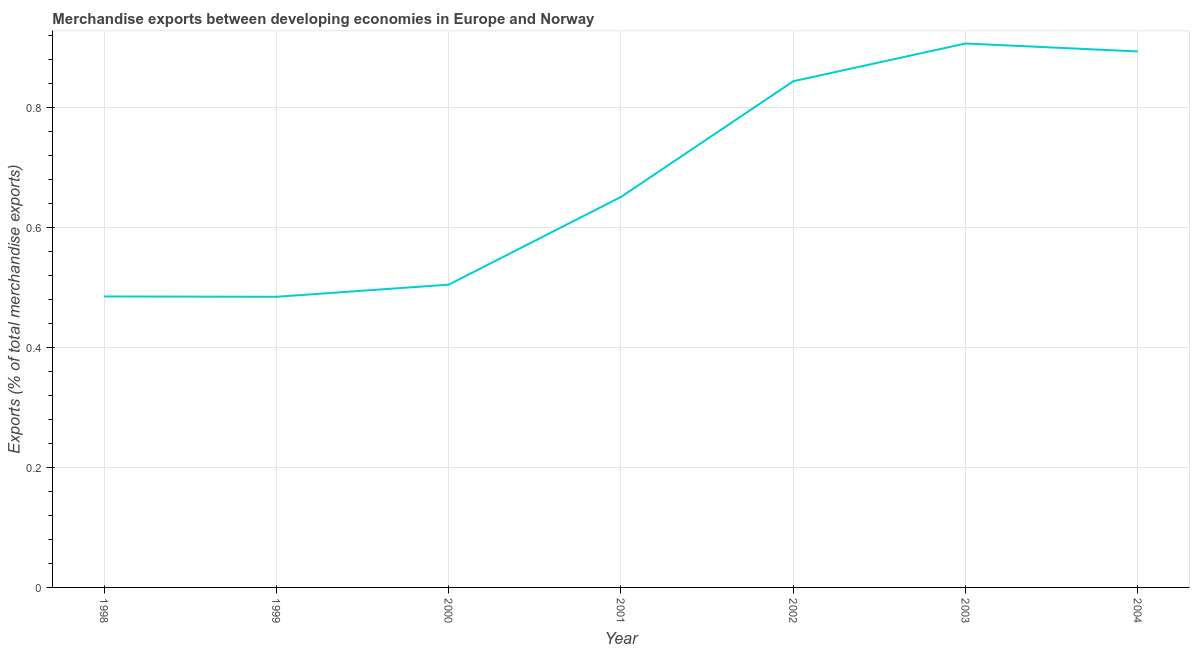What is the merchandise exports in 1998?
Your response must be concise. 0.49. Across all years, what is the maximum merchandise exports?
Provide a short and direct response. 0.91. Across all years, what is the minimum merchandise exports?
Ensure brevity in your answer.  0.48. In which year was the merchandise exports maximum?
Make the answer very short. 2003. In which year was the merchandise exports minimum?
Your response must be concise. 1999. What is the sum of the merchandise exports?
Your response must be concise. 4.77. What is the difference between the merchandise exports in 2003 and 2004?
Offer a very short reply. 0.01. What is the average merchandise exports per year?
Give a very brief answer. 0.68. What is the median merchandise exports?
Ensure brevity in your answer.  0.65. What is the ratio of the merchandise exports in 1998 to that in 2000?
Provide a short and direct response. 0.96. Is the difference between the merchandise exports in 2002 and 2004 greater than the difference between any two years?
Keep it short and to the point. No. What is the difference between the highest and the second highest merchandise exports?
Make the answer very short. 0.01. Is the sum of the merchandise exports in 1998 and 1999 greater than the maximum merchandise exports across all years?
Your answer should be compact. Yes. What is the difference between the highest and the lowest merchandise exports?
Give a very brief answer. 0.42. Does the merchandise exports monotonically increase over the years?
Offer a very short reply. No. Are the values on the major ticks of Y-axis written in scientific E-notation?
Offer a terse response. No. Does the graph contain any zero values?
Your answer should be very brief. No. What is the title of the graph?
Offer a very short reply. Merchandise exports between developing economies in Europe and Norway. What is the label or title of the X-axis?
Offer a very short reply. Year. What is the label or title of the Y-axis?
Make the answer very short. Exports (% of total merchandise exports). What is the Exports (% of total merchandise exports) in 1998?
Offer a very short reply. 0.49. What is the Exports (% of total merchandise exports) of 1999?
Give a very brief answer. 0.48. What is the Exports (% of total merchandise exports) of 2000?
Offer a very short reply. 0.51. What is the Exports (% of total merchandise exports) of 2001?
Your answer should be compact. 0.65. What is the Exports (% of total merchandise exports) in 2002?
Make the answer very short. 0.84. What is the Exports (% of total merchandise exports) in 2003?
Ensure brevity in your answer.  0.91. What is the Exports (% of total merchandise exports) of 2004?
Offer a terse response. 0.89. What is the difference between the Exports (% of total merchandise exports) in 1998 and 1999?
Ensure brevity in your answer.  0. What is the difference between the Exports (% of total merchandise exports) in 1998 and 2000?
Make the answer very short. -0.02. What is the difference between the Exports (% of total merchandise exports) in 1998 and 2001?
Make the answer very short. -0.17. What is the difference between the Exports (% of total merchandise exports) in 1998 and 2002?
Your answer should be compact. -0.36. What is the difference between the Exports (% of total merchandise exports) in 1998 and 2003?
Your response must be concise. -0.42. What is the difference between the Exports (% of total merchandise exports) in 1998 and 2004?
Offer a very short reply. -0.41. What is the difference between the Exports (% of total merchandise exports) in 1999 and 2000?
Make the answer very short. -0.02. What is the difference between the Exports (% of total merchandise exports) in 1999 and 2001?
Provide a short and direct response. -0.17. What is the difference between the Exports (% of total merchandise exports) in 1999 and 2002?
Offer a very short reply. -0.36. What is the difference between the Exports (% of total merchandise exports) in 1999 and 2003?
Your answer should be compact. -0.42. What is the difference between the Exports (% of total merchandise exports) in 1999 and 2004?
Your answer should be very brief. -0.41. What is the difference between the Exports (% of total merchandise exports) in 2000 and 2001?
Give a very brief answer. -0.15. What is the difference between the Exports (% of total merchandise exports) in 2000 and 2002?
Provide a short and direct response. -0.34. What is the difference between the Exports (% of total merchandise exports) in 2000 and 2003?
Provide a succinct answer. -0.4. What is the difference between the Exports (% of total merchandise exports) in 2000 and 2004?
Offer a very short reply. -0.39. What is the difference between the Exports (% of total merchandise exports) in 2001 and 2002?
Your answer should be compact. -0.19. What is the difference between the Exports (% of total merchandise exports) in 2001 and 2003?
Ensure brevity in your answer.  -0.26. What is the difference between the Exports (% of total merchandise exports) in 2001 and 2004?
Your answer should be compact. -0.24. What is the difference between the Exports (% of total merchandise exports) in 2002 and 2003?
Make the answer very short. -0.06. What is the difference between the Exports (% of total merchandise exports) in 2002 and 2004?
Your answer should be compact. -0.05. What is the difference between the Exports (% of total merchandise exports) in 2003 and 2004?
Offer a terse response. 0.01. What is the ratio of the Exports (% of total merchandise exports) in 1998 to that in 2001?
Give a very brief answer. 0.74. What is the ratio of the Exports (% of total merchandise exports) in 1998 to that in 2002?
Make the answer very short. 0.57. What is the ratio of the Exports (% of total merchandise exports) in 1998 to that in 2003?
Provide a short and direct response. 0.54. What is the ratio of the Exports (% of total merchandise exports) in 1998 to that in 2004?
Provide a succinct answer. 0.54. What is the ratio of the Exports (% of total merchandise exports) in 1999 to that in 2000?
Keep it short and to the point. 0.96. What is the ratio of the Exports (% of total merchandise exports) in 1999 to that in 2001?
Provide a succinct answer. 0.74. What is the ratio of the Exports (% of total merchandise exports) in 1999 to that in 2002?
Ensure brevity in your answer.  0.57. What is the ratio of the Exports (% of total merchandise exports) in 1999 to that in 2003?
Your answer should be very brief. 0.53. What is the ratio of the Exports (% of total merchandise exports) in 1999 to that in 2004?
Ensure brevity in your answer.  0.54. What is the ratio of the Exports (% of total merchandise exports) in 2000 to that in 2001?
Make the answer very short. 0.78. What is the ratio of the Exports (% of total merchandise exports) in 2000 to that in 2002?
Make the answer very short. 0.6. What is the ratio of the Exports (% of total merchandise exports) in 2000 to that in 2003?
Your answer should be very brief. 0.56. What is the ratio of the Exports (% of total merchandise exports) in 2000 to that in 2004?
Offer a very short reply. 0.56. What is the ratio of the Exports (% of total merchandise exports) in 2001 to that in 2002?
Give a very brief answer. 0.77. What is the ratio of the Exports (% of total merchandise exports) in 2001 to that in 2003?
Offer a terse response. 0.72. What is the ratio of the Exports (% of total merchandise exports) in 2001 to that in 2004?
Your answer should be compact. 0.73. What is the ratio of the Exports (% of total merchandise exports) in 2002 to that in 2004?
Provide a succinct answer. 0.94. 